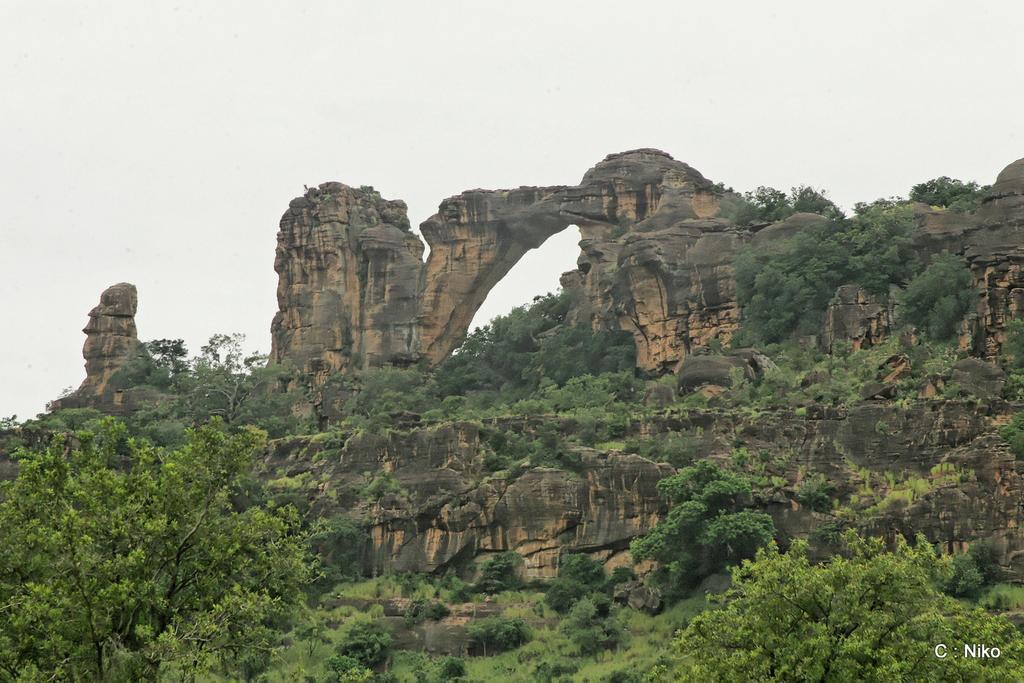How would you summarize this image in a sentence or two? In the image we can see trees, plants and grass. Here we can see the rocks, the sky and on the bottom right we can see the watermark. 